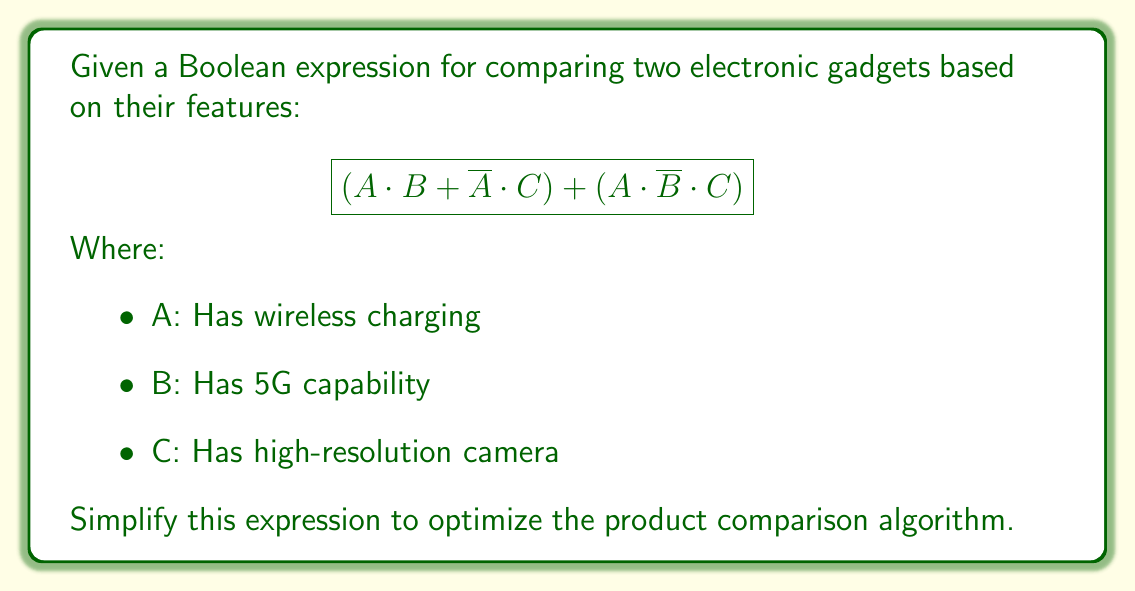Can you solve this math problem? Let's simplify this Boolean expression step-by-step:

1) First, let's distribute the second term:
   $$(A \cdot B + \overline{A} \cdot C) + (A \cdot \overline{B} \cdot C)$$
   $$= A \cdot B + \overline{A} \cdot C + A \cdot \overline{B} \cdot C$$

2) Now, we can factor out C from the last two terms:
   $$= A \cdot B + (\overline{A} + A \cdot \overline{B}) \cdot C$$

3) Inside the parentheses, we can apply one of De Morgan's laws:
   $\overline{A} + A \cdot \overline{B} = \overline{A} + \overline{(\overline{A} + B)}$

4) This is the definition of the implication operator, so we can simplify:
   $$= A \cdot B + (B \rightarrow A) \cdot C$$

5) Now, we can use the identity $X + Y = X + \overline{X} \cdot Y$:
   $$= A \cdot B + A \cdot C + \overline{A} \cdot (B \rightarrow A) \cdot C$$

6) Simplify the last term:
   $\overline{A} \cdot (B \rightarrow A) = \overline{A} \cdot (\overline{B} + A) = \overline{A} \cdot \overline{B}$

7) Therefore, our final simplified expression is:
   $$A \cdot B + A \cdot C + \overline{A} \cdot \overline{B} \cdot C$$

This simplified form reduces the number of operations needed in the product comparison algorithm, making it more efficient.
Answer: $$A \cdot B + A \cdot C + \overline{A} \cdot \overline{B} \cdot C$$ 